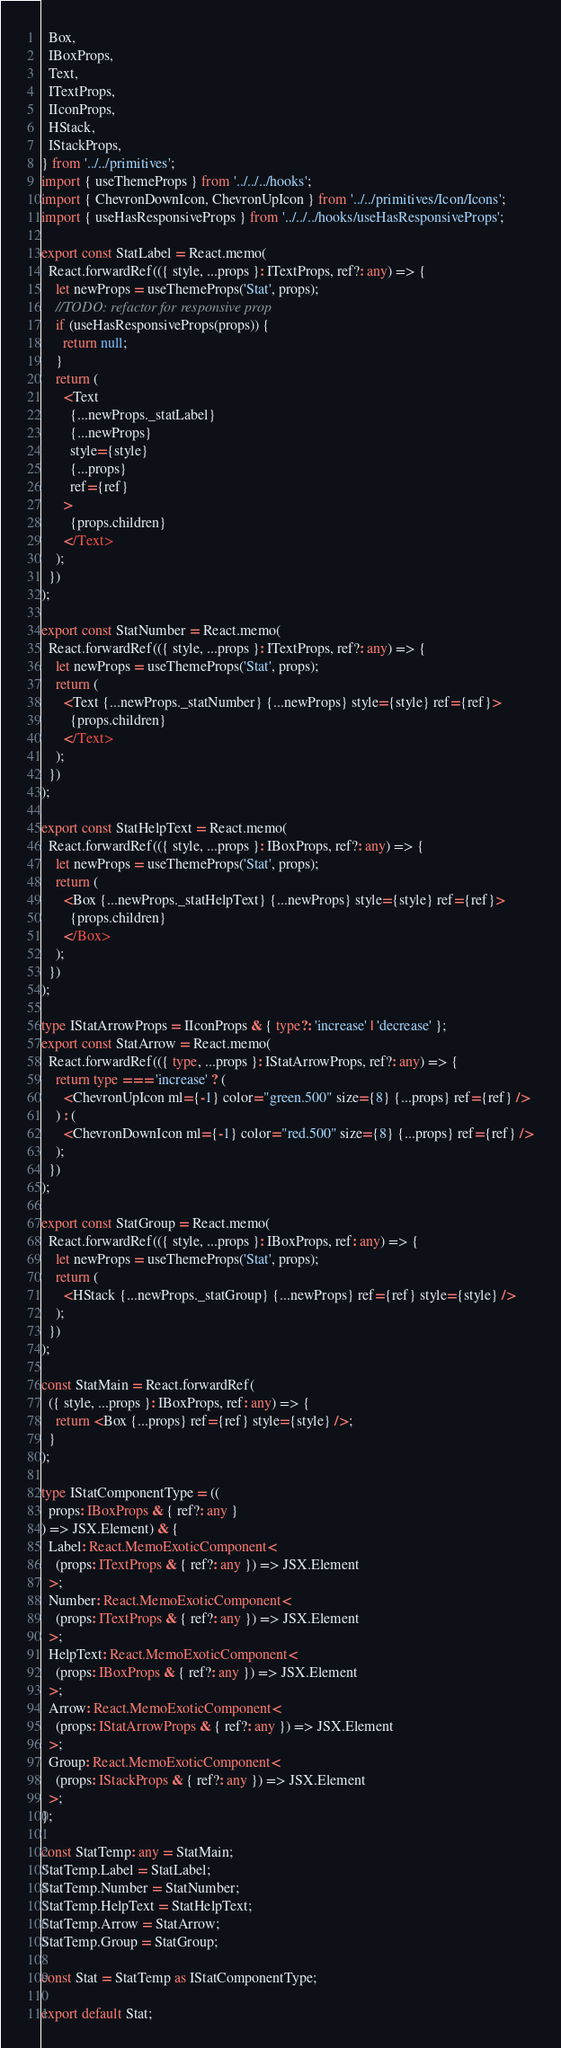<code> <loc_0><loc_0><loc_500><loc_500><_TypeScript_>  Box,
  IBoxProps,
  Text,
  ITextProps,
  IIconProps,
  HStack,
  IStackProps,
} from '../../primitives';
import { useThemeProps } from '../../../hooks';
import { ChevronDownIcon, ChevronUpIcon } from '../../primitives/Icon/Icons';
import { useHasResponsiveProps } from '../../../hooks/useHasResponsiveProps';

export const StatLabel = React.memo(
  React.forwardRef(({ style, ...props }: ITextProps, ref?: any) => {
    let newProps = useThemeProps('Stat', props);
    //TODO: refactor for responsive prop
    if (useHasResponsiveProps(props)) {
      return null;
    }
    return (
      <Text
        {...newProps._statLabel}
        {...newProps}
        style={style}
        {...props}
        ref={ref}
      >
        {props.children}
      </Text>
    );
  })
);

export const StatNumber = React.memo(
  React.forwardRef(({ style, ...props }: ITextProps, ref?: any) => {
    let newProps = useThemeProps('Stat', props);
    return (
      <Text {...newProps._statNumber} {...newProps} style={style} ref={ref}>
        {props.children}
      </Text>
    );
  })
);

export const StatHelpText = React.memo(
  React.forwardRef(({ style, ...props }: IBoxProps, ref?: any) => {
    let newProps = useThemeProps('Stat', props);
    return (
      <Box {...newProps._statHelpText} {...newProps} style={style} ref={ref}>
        {props.children}
      </Box>
    );
  })
);

type IStatArrowProps = IIconProps & { type?: 'increase' | 'decrease' };
export const StatArrow = React.memo(
  React.forwardRef(({ type, ...props }: IStatArrowProps, ref?: any) => {
    return type === 'increase' ? (
      <ChevronUpIcon ml={-1} color="green.500" size={8} {...props} ref={ref} />
    ) : (
      <ChevronDownIcon ml={-1} color="red.500" size={8} {...props} ref={ref} />
    );
  })
);

export const StatGroup = React.memo(
  React.forwardRef(({ style, ...props }: IBoxProps, ref: any) => {
    let newProps = useThemeProps('Stat', props);
    return (
      <HStack {...newProps._statGroup} {...newProps} ref={ref} style={style} />
    );
  })
);

const StatMain = React.forwardRef(
  ({ style, ...props }: IBoxProps, ref: any) => {
    return <Box {...props} ref={ref} style={style} />;
  }
);

type IStatComponentType = ((
  props: IBoxProps & { ref?: any }
) => JSX.Element) & {
  Label: React.MemoExoticComponent<
    (props: ITextProps & { ref?: any }) => JSX.Element
  >;
  Number: React.MemoExoticComponent<
    (props: ITextProps & { ref?: any }) => JSX.Element
  >;
  HelpText: React.MemoExoticComponent<
    (props: IBoxProps & { ref?: any }) => JSX.Element
  >;
  Arrow: React.MemoExoticComponent<
    (props: IStatArrowProps & { ref?: any }) => JSX.Element
  >;
  Group: React.MemoExoticComponent<
    (props: IStackProps & { ref?: any }) => JSX.Element
  >;
};

const StatTemp: any = StatMain;
StatTemp.Label = StatLabel;
StatTemp.Number = StatNumber;
StatTemp.HelpText = StatHelpText;
StatTemp.Arrow = StatArrow;
StatTemp.Group = StatGroup;

const Stat = StatTemp as IStatComponentType;

export default Stat;
</code> 